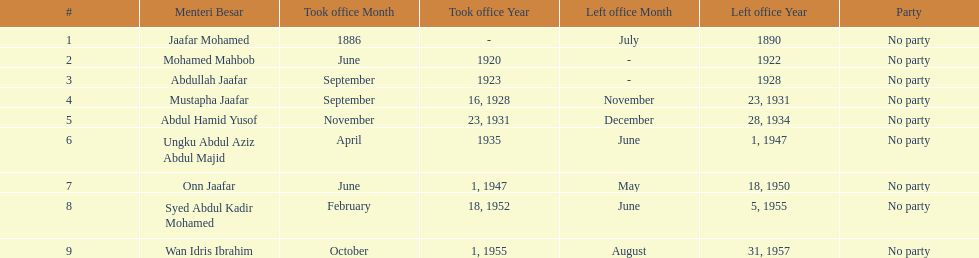Parse the full table. {'header': ['#', 'Menteri Besar', 'Took office Month', 'Took office Year', 'Left office Month', 'Left office Year', 'Party'], 'rows': [['1', 'Jaafar Mohamed', '1886', '-', 'July', '1890', 'No party'], ['2', 'Mohamed Mahbob', 'June', '1920', '-', '1922', 'No party'], ['3', 'Abdullah Jaafar', 'September', '1923', '-', '1928', 'No party'], ['4', 'Mustapha Jaafar', 'September', '16, 1928', 'November', '23, 1931', 'No party'], ['5', 'Abdul Hamid Yusof', 'November', '23, 1931', 'December', '28, 1934', 'No party'], ['6', 'Ungku Abdul Aziz Abdul Majid', 'April', '1935', 'June', '1, 1947', 'No party'], ['7', 'Onn Jaafar', 'June', '1, 1947', 'May', '18, 1950', 'No party'], ['8', 'Syed Abdul Kadir Mohamed', 'February', '18, 1952', 'June', '5, 1955', 'No party'], ['9', 'Wan Idris Ibrahim', 'October', '1, 1955', 'August', '31, 1957', 'No party']]} What was the date the last person on the list left office? August 31, 1957. 